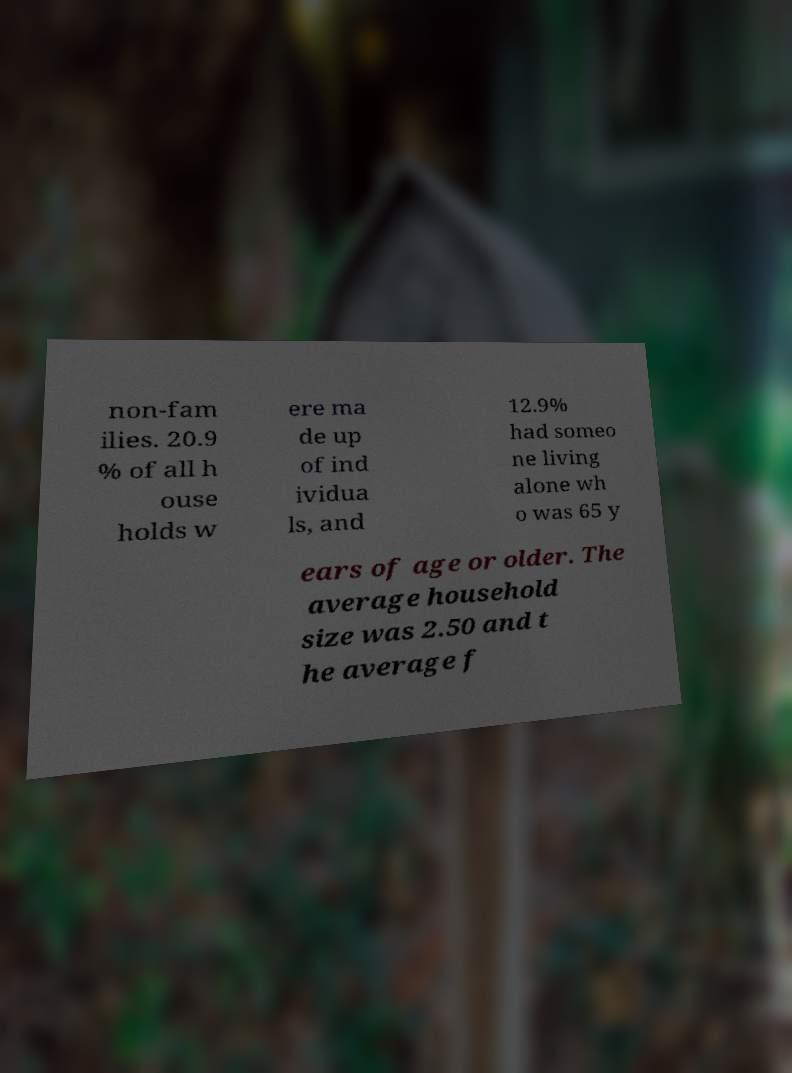What messages or text are displayed in this image? I need them in a readable, typed format. non-fam ilies. 20.9 % of all h ouse holds w ere ma de up of ind ividua ls, and 12.9% had someo ne living alone wh o was 65 y ears of age or older. The average household size was 2.50 and t he average f 